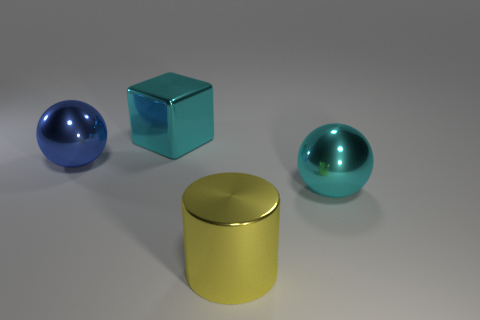There is a metallic object that is the same color as the cube; what is its shape?
Your answer should be compact. Sphere. Is there anything else that has the same color as the block?
Keep it short and to the point. Yes. What size is the cyan metal thing that is left of the large cylinder?
Your answer should be very brief. Large. What is the material of the large cyan object that is the same shape as the large blue metallic thing?
Offer a very short reply. Metal. The large object that is both on the right side of the blue metal thing and left of the big yellow metallic object has what shape?
Give a very brief answer. Cube. What is the shape of the blue thing that is the same material as the big cyan block?
Make the answer very short. Sphere. There is a large cyan object that is to the left of the large cyan sphere; what material is it?
Offer a very short reply. Metal. Is the size of the blue shiny sphere that is on the left side of the yellow metallic cylinder the same as the sphere on the right side of the large cyan shiny block?
Offer a terse response. Yes. What color is the block?
Your answer should be very brief. Cyan. Do the cyan thing that is in front of the block and the blue object have the same shape?
Offer a very short reply. Yes. 